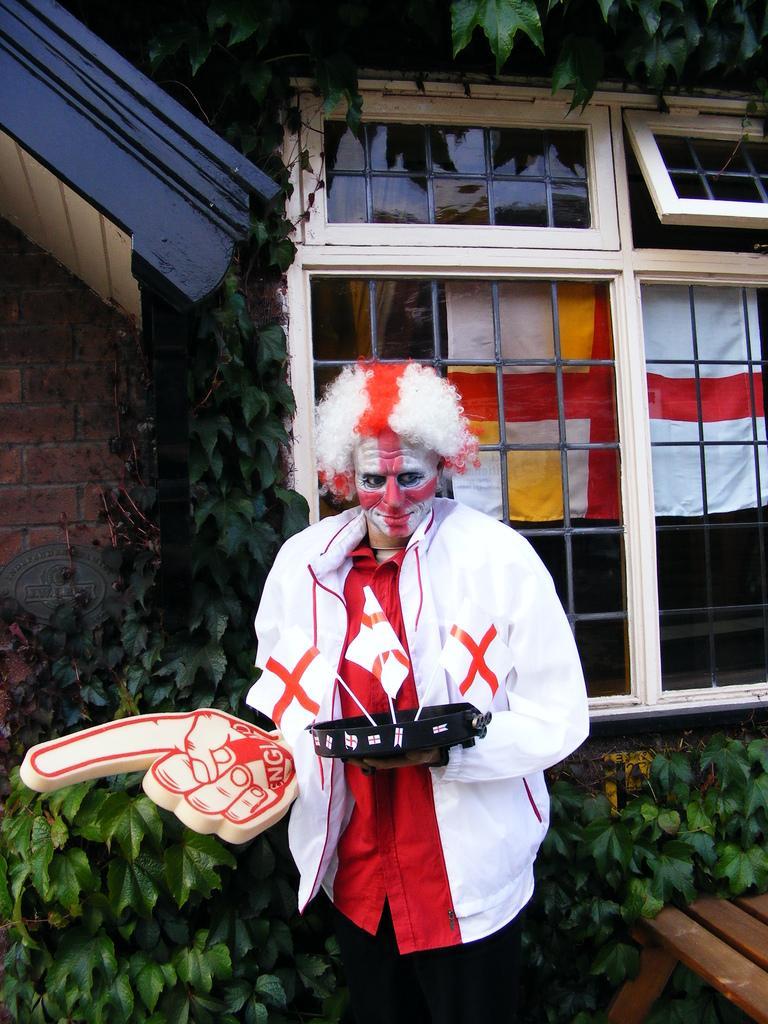Can you describe this image briefly? In this picture we can see a man, flags, wooden object, some objects and in the background we can see clothes, windows, plants, wall. 